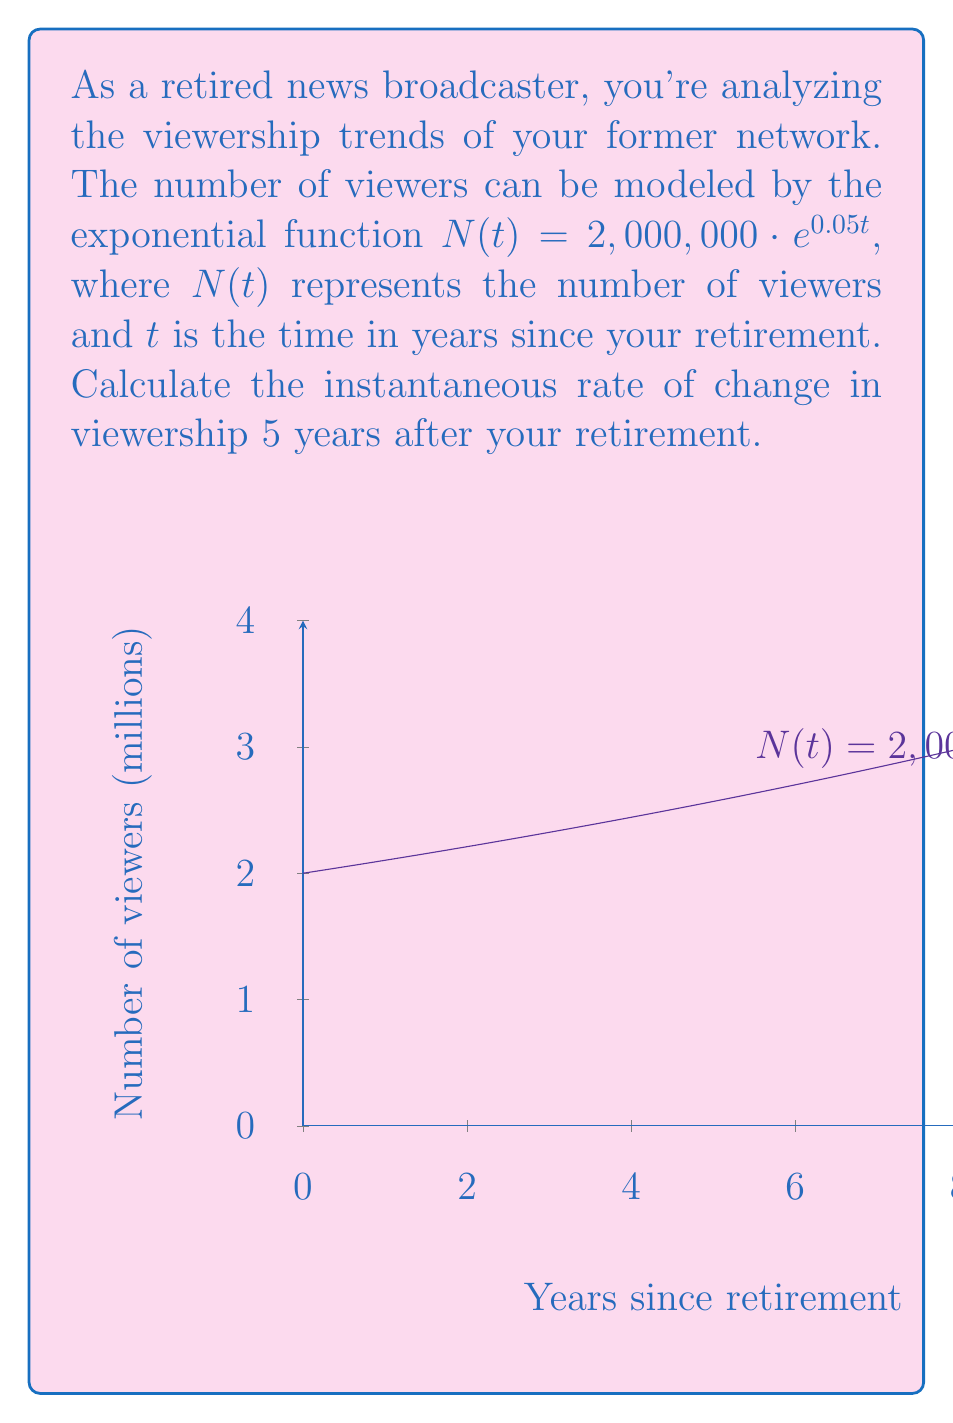Help me with this question. To find the instantaneous rate of change, we need to calculate the derivative of the function $N(t)$ and evaluate it at $t=5$. Let's proceed step-by-step:

1) The given function is $N(t) = 2,000,000 \cdot e^{0.05t}$

2) To find the derivative, we use the chain rule:
   $$\frac{d}{dt}N(t) = 2,000,000 \cdot \frac{d}{dt}(e^{0.05t})$$
   $$\frac{d}{dt}N(t) = 2,000,000 \cdot 0.05 \cdot e^{0.05t}$$
   $$\frac{d}{dt}N(t) = 100,000 \cdot e^{0.05t}$$

3) Now, we evaluate this derivative at $t=5$:
   $$\frac{d}{dt}N(5) = 100,000 \cdot e^{0.05 \cdot 5}$$
   $$\frac{d}{dt}N(5) = 100,000 \cdot e^{0.25}$$

4) Calculate $e^{0.25}$ (you can use a calculator for this):
   $$e^{0.25} \approx 1.2840$$

5) Multiply this by 100,000:
   $$100,000 \cdot 1.2840 = 128,400$$

Therefore, the instantaneous rate of change in viewership 5 years after your retirement is approximately 128,400 viewers per year.
Answer: 128,400 viewers/year 